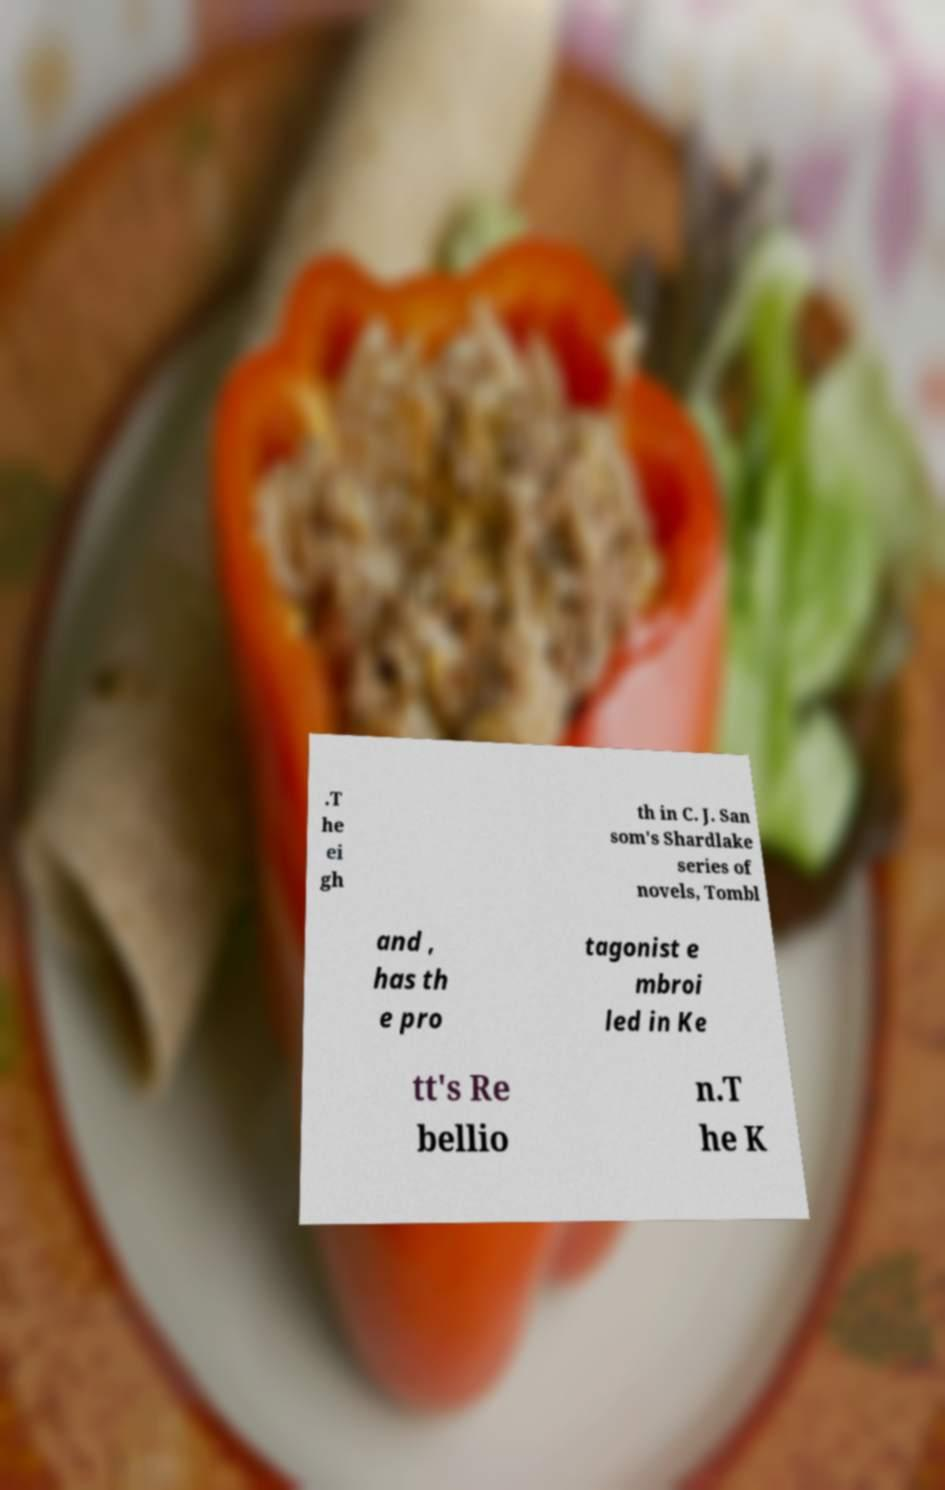For documentation purposes, I need the text within this image transcribed. Could you provide that? .T he ei gh th in C. J. San som's Shardlake series of novels, Tombl and , has th e pro tagonist e mbroi led in Ke tt's Re bellio n.T he K 